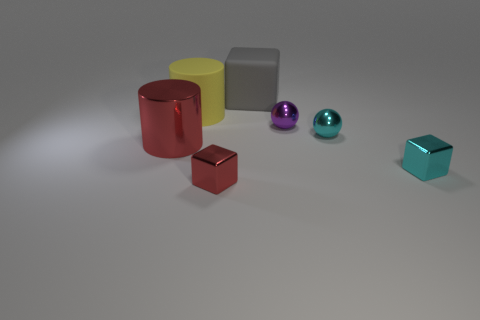Add 2 large purple balls. How many objects exist? 9 Subtract all cylinders. How many objects are left? 5 Subtract all red cylinders. Subtract all large gray matte things. How many objects are left? 5 Add 6 matte things. How many matte things are left? 8 Add 2 tiny cyan metal objects. How many tiny cyan metal objects exist? 4 Subtract 1 red cylinders. How many objects are left? 6 